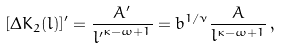<formula> <loc_0><loc_0><loc_500><loc_500>[ \Delta K _ { 2 } ( l ) ] ^ { \prime } = \frac { A ^ { \prime } } { { l ^ { \prime } } ^ { \kappa - \omega + 1 } } = b ^ { 1 / \nu } \frac { A } { l ^ { \kappa - \omega + 1 } } \, ,</formula> 